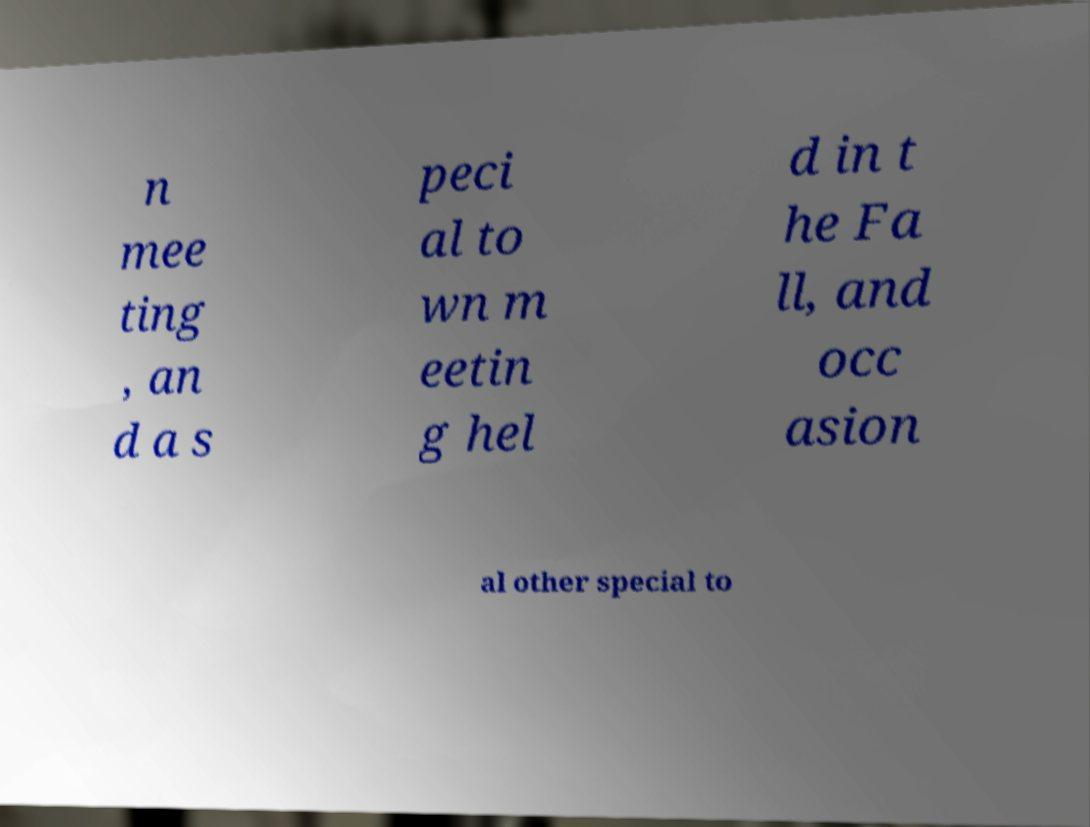Please identify and transcribe the text found in this image. n mee ting , an d a s peci al to wn m eetin g hel d in t he Fa ll, and occ asion al other special to 